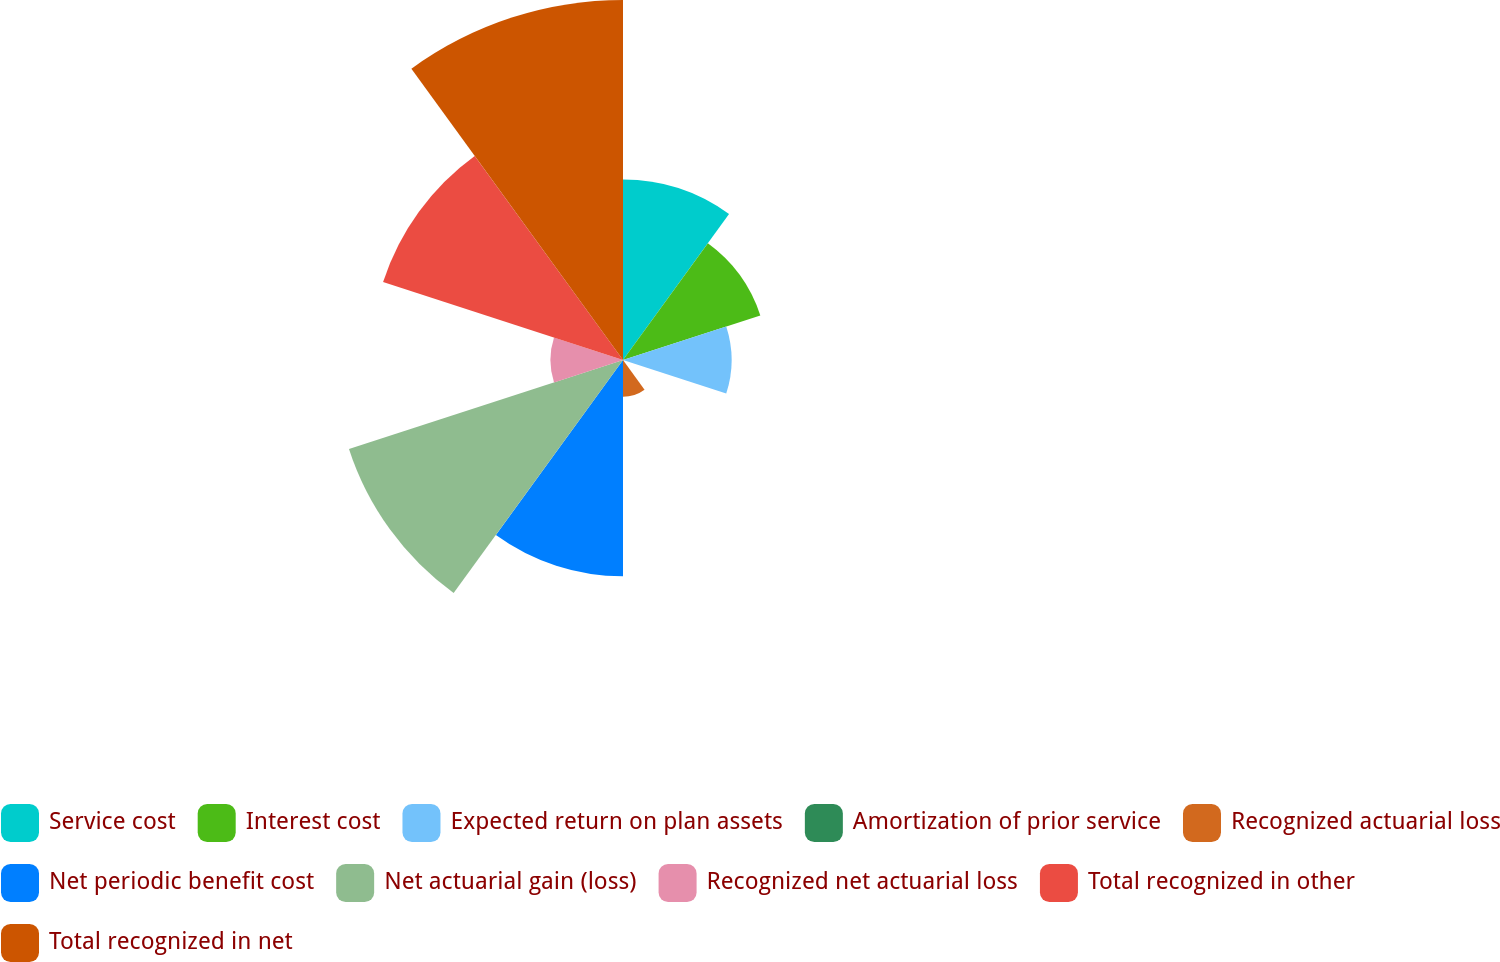Convert chart. <chart><loc_0><loc_0><loc_500><loc_500><pie_chart><fcel>Service cost<fcel>Interest cost<fcel>Expected return on plan assets<fcel>Amortization of prior service<fcel>Recognized actuarial loss<fcel>Net periodic benefit cost<fcel>Net actuarial gain (loss)<fcel>Recognized net actuarial loss<fcel>Total recognized in other<fcel>Total recognized in net<nl><fcel>10.87%<fcel>8.7%<fcel>6.54%<fcel>0.04%<fcel>2.21%<fcel>13.03%<fcel>17.36%<fcel>4.37%<fcel>15.2%<fcel>21.69%<nl></chart> 